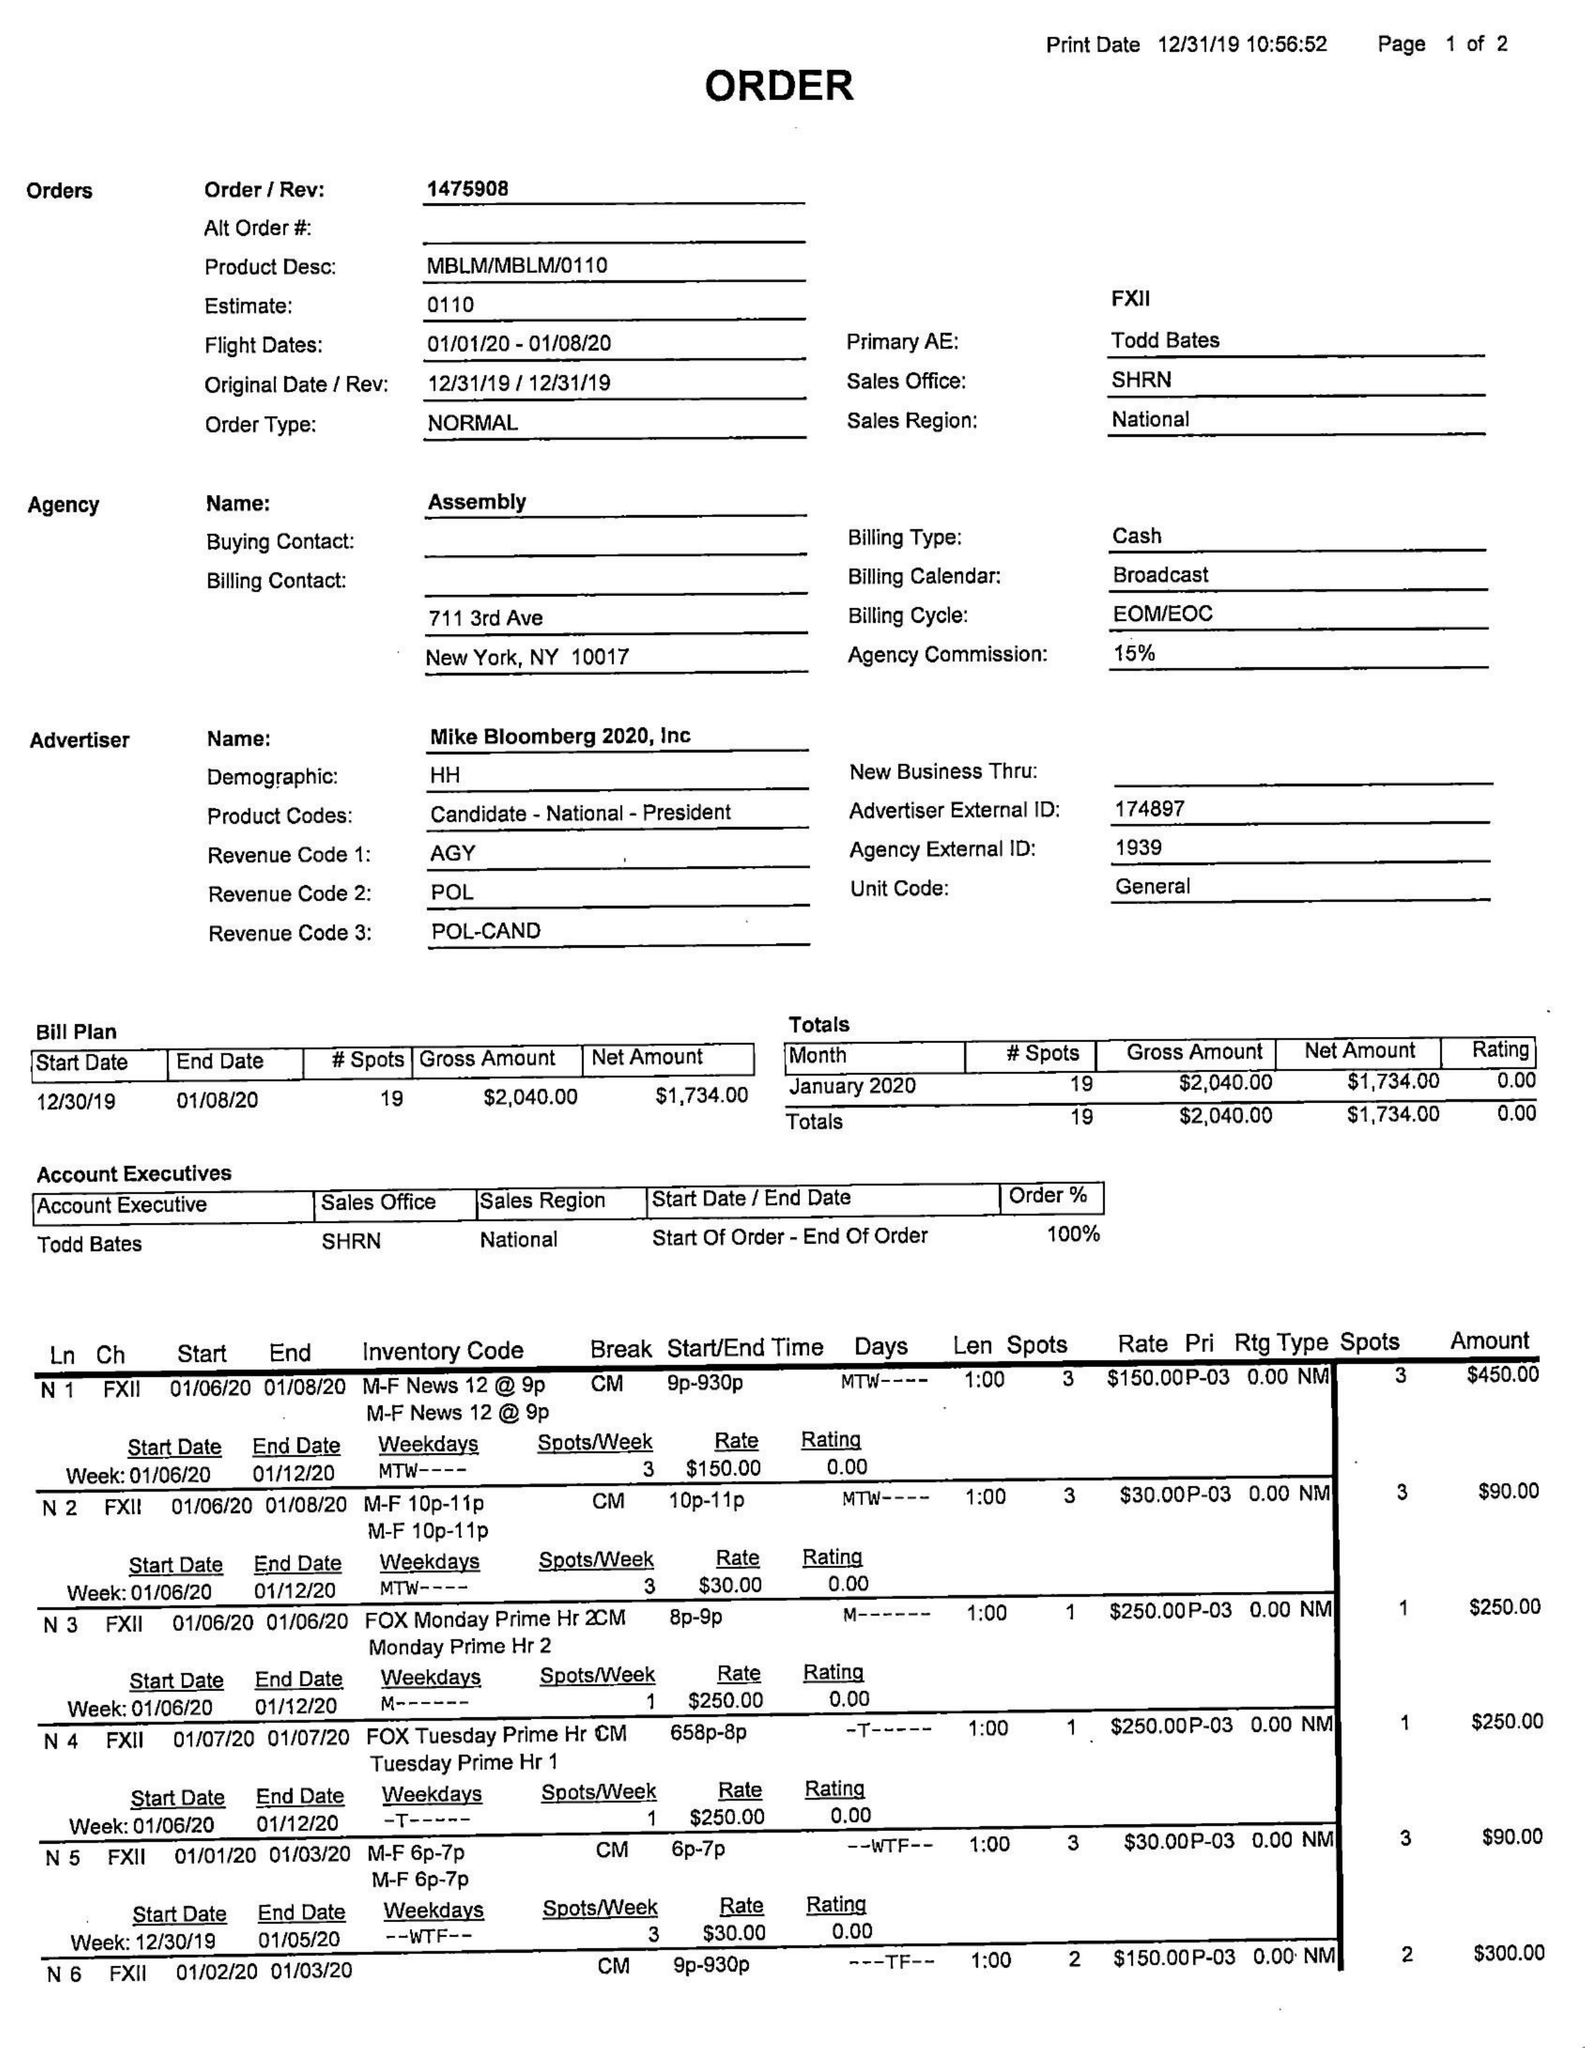What is the value for the flight_from?
Answer the question using a single word or phrase. 01/01/20 